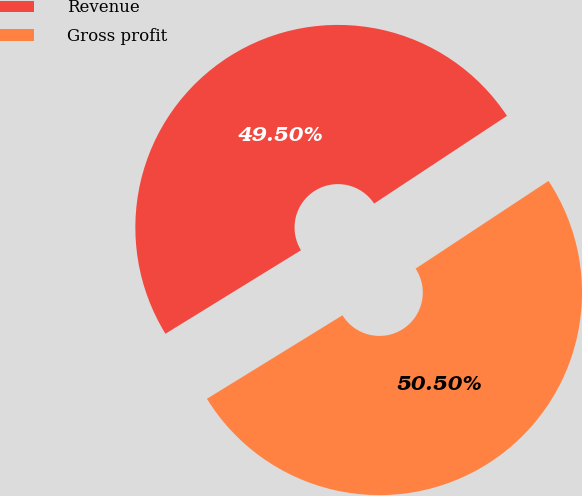<chart> <loc_0><loc_0><loc_500><loc_500><pie_chart><fcel>Revenue<fcel>Gross profit<nl><fcel>49.5%<fcel>50.5%<nl></chart> 